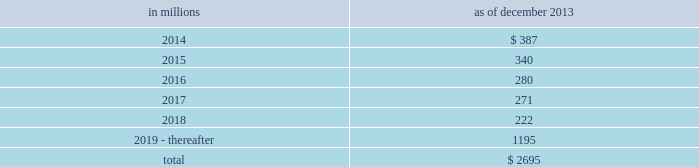Notes to consolidated financial statements sumitomo mitsui financial group , inc .
( smfg ) provides the firm with credit loss protection on certain approved loan commitments ( primarily investment-grade commercial lending commitments ) .
The notional amount of such loan commitments was $ 29.24 billion and $ 32.41 billion as of december 2013 and december 2012 , respectively .
The credit loss protection on loan commitments provided by smfg is generally limited to 95% ( 95 % ) of the first loss the firm realizes on such commitments , up to a maximum of approximately $ 950 million .
In addition , subject to the satisfaction of certain conditions , upon the firm 2019s request , smfg will provide protection for 70% ( 70 % ) of additional losses on such commitments , up to a maximum of $ 1.13 billion , of which $ 870 million and $ 300 million of protection had been provided as of december 2013 and december 2012 , respectively .
The firm also uses other financial instruments to mitigate credit risks related to certain commitments not covered by smfg .
These instruments primarily include credit default swaps that reference the same or similar underlying instrument or entity , or credit default swaps that reference a market index .
Warehouse financing .
The firm provides financing to clients who warehouse financial assets .
These arrangements are secured by the warehoused assets , primarily consisting of corporate loans and commercial mortgage loans .
Contingent and forward starting resale and securities borrowing agreements/forward starting repurchase and secured lending agreements the firm enters into resale and securities borrowing agreements and repurchase and secured lending agreements that settle at a future date , generally within three business days .
The firm also enters into commitments to provide contingent financing to its clients and counterparties through resale agreements .
The firm 2019s funding of these commitments depends on the satisfaction of all contractual conditions to the resale agreement and these commitments can expire unused .
Investment commitments the firm 2019s investment commitments consist of commitments to invest in private equity , real estate and other assets directly and through funds that the firm raises and manages .
These commitments include $ 659 million and $ 872 million as of december 2013 and december 2012 , respectively , related to real estate private investments and $ 6.46 billion and $ 6.47 billion as of december 2013 and december 2012 , respectively , related to corporate and other private investments .
Of these amounts , $ 5.48 billion and $ 6.21 billion as of december 2013 and december 2012 , respectively , relate to commitments to invest in funds managed by the firm .
If these commitments are called , they would be funded at market value on the date of investment .
Leases the firm has contractual obligations under long-term noncancelable lease agreements , principally for office space , expiring on various dates through 2069 .
Certain agreements are subject to periodic escalation provisions for increases in real estate taxes and other charges .
The table below presents future minimum rental payments , net of minimum sublease rentals .
In millions december 2013 .
Rent charged to operating expense was $ 324 million for 2013 , $ 374 million for 2012 and $ 475 million for 2011 .
Operating leases include office space held in excess of current requirements .
Rent expense relating to space held for growth is included in 201coccupancy . 201d the firm records a liability , based on the fair value of the remaining lease rentals reduced by any potential or existing sublease rentals , for leases where the firm has ceased using the space and management has concluded that the firm will not derive any future economic benefits .
Costs to terminate a lease before the end of its term are recognized and measured at fair value on termination .
Contingencies legal proceedings .
See note 27 for information about legal proceedings , including certain mortgage-related matters .
Certain mortgage-related contingencies .
There are multiple areas of focus by regulators , governmental agencies and others within the mortgage market that may impact originators , issuers , servicers and investors .
There remains significant uncertainty surrounding the nature and extent of any potential exposure for participants in this market .
182 goldman sachs 2013 annual report .
What was total rent charged to operating expense in millions for 2013 , 2012 and 2011? 
Computations: ((324 + 374) + 475)
Answer: 1173.0. 